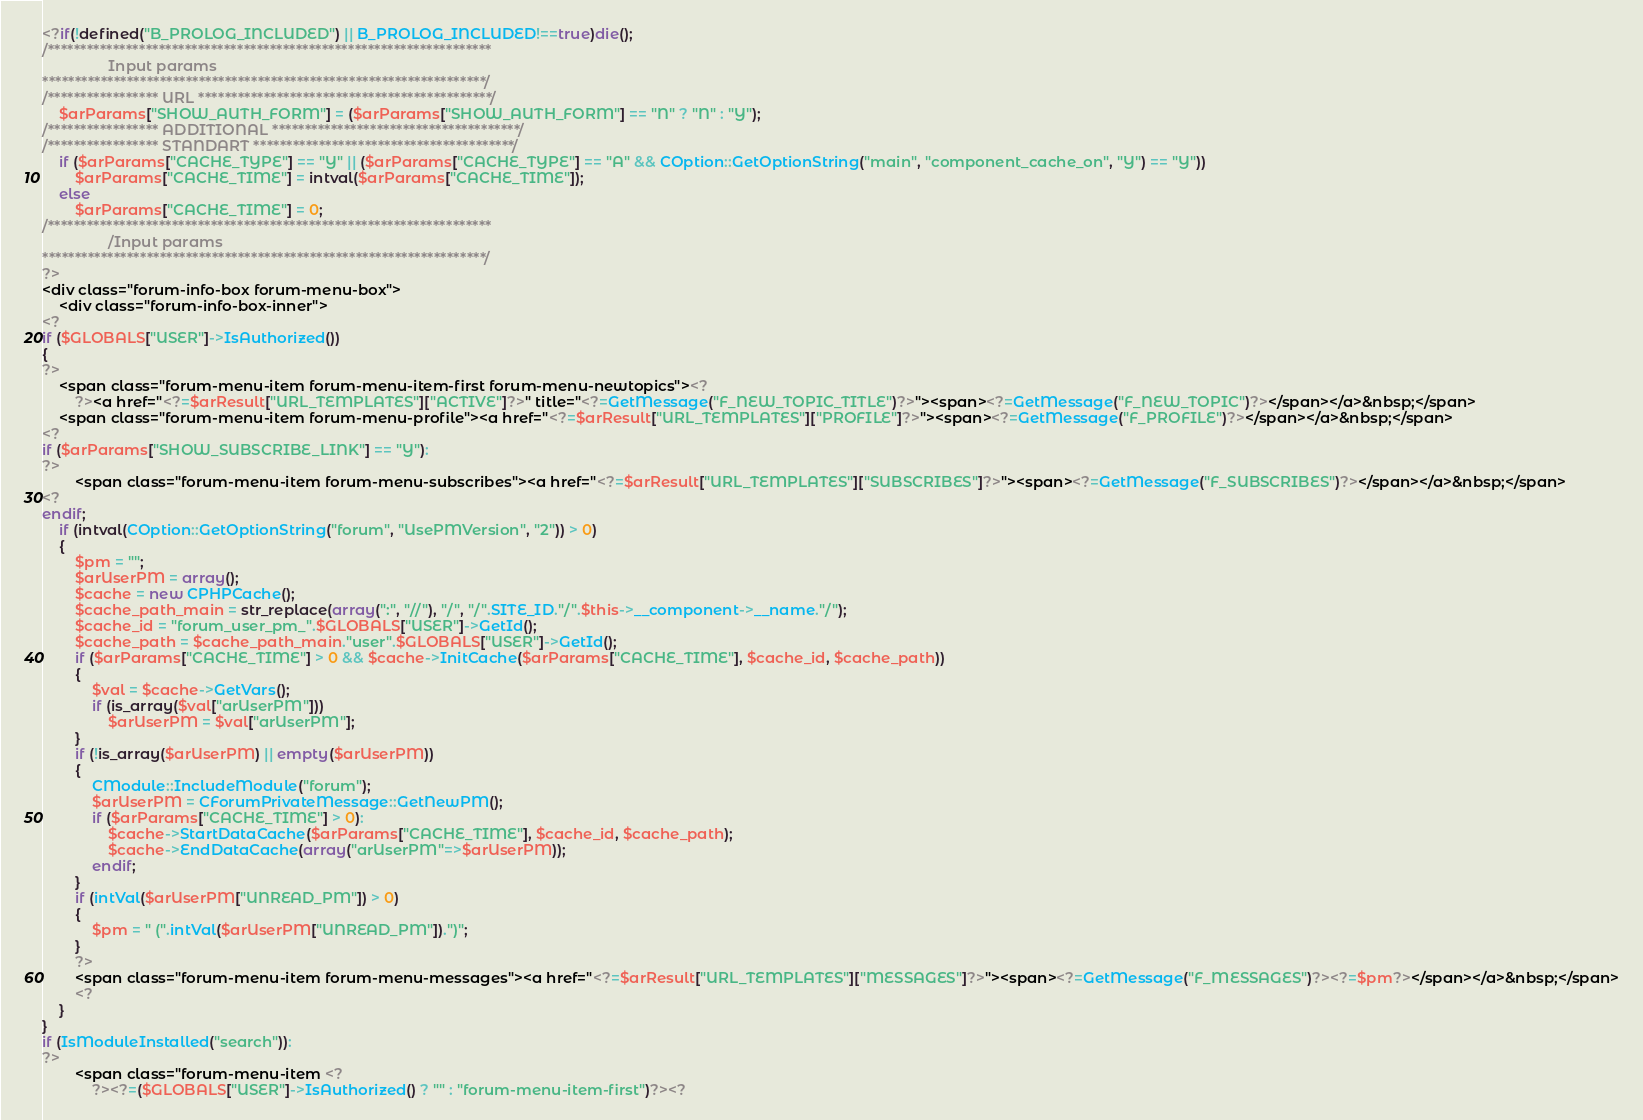Convert code to text. <code><loc_0><loc_0><loc_500><loc_500><_PHP_><?if(!defined("B_PROLOG_INCLUDED") || B_PROLOG_INCLUDED!==true)die();
/********************************************************************
				Input params
********************************************************************/
/***************** URL *********************************************/
	$arParams["SHOW_AUTH_FORM"] = ($arParams["SHOW_AUTH_FORM"] == "N" ? "N" : "Y");
/***************** ADDITIONAL **************************************/
/***************** STANDART ****************************************/
	if ($arParams["CACHE_TYPE"] == "Y" || ($arParams["CACHE_TYPE"] == "A" && COption::GetOptionString("main", "component_cache_on", "Y") == "Y"))
		$arParams["CACHE_TIME"] = intval($arParams["CACHE_TIME"]);
	else
		$arParams["CACHE_TIME"] = 0;
/********************************************************************
				/Input params
********************************************************************/
?>
<div class="forum-info-box forum-menu-box">
	<div class="forum-info-box-inner">
<?
if ($GLOBALS["USER"]->IsAuthorized())
{
?>
	<span class="forum-menu-item forum-menu-item-first forum-menu-newtopics"><?
		?><a href="<?=$arResult["URL_TEMPLATES"]["ACTIVE"]?>" title="<?=GetMessage("F_NEW_TOPIC_TITLE")?>"><span><?=GetMessage("F_NEW_TOPIC")?></span></a>&nbsp;</span>
	<span class="forum-menu-item forum-menu-profile"><a href="<?=$arResult["URL_TEMPLATES"]["PROFILE"]?>"><span><?=GetMessage("F_PROFILE")?></span></a>&nbsp;</span>
<?
if ($arParams["SHOW_SUBSCRIBE_LINK"] == "Y"):
?>
		<span class="forum-menu-item forum-menu-subscribes"><a href="<?=$arResult["URL_TEMPLATES"]["SUBSCRIBES"]?>"><span><?=GetMessage("F_SUBSCRIBES")?></span></a>&nbsp;</span>
<?
endif;
	if (intval(COption::GetOptionString("forum", "UsePMVersion", "2")) > 0)
	{
		$pm = "";
		$arUserPM = array();
		$cache = new CPHPCache();
		$cache_path_main = str_replace(array(":", "//"), "/", "/".SITE_ID."/".$this->__component->__name."/");
		$cache_id = "forum_user_pm_".$GLOBALS["USER"]->GetId();
		$cache_path = $cache_path_main."user".$GLOBALS["USER"]->GetId();
		if ($arParams["CACHE_TIME"] > 0 && $cache->InitCache($arParams["CACHE_TIME"], $cache_id, $cache_path))
		{
			$val = $cache->GetVars();
			if (is_array($val["arUserPM"]))
				$arUserPM = $val["arUserPM"];
		}
		if (!is_array($arUserPM) || empty($arUserPM))
		{
			CModule::IncludeModule("forum");
			$arUserPM = CForumPrivateMessage::GetNewPM();
			if ($arParams["CACHE_TIME"] > 0):
				$cache->StartDataCache($arParams["CACHE_TIME"], $cache_id, $cache_path);
				$cache->EndDataCache(array("arUserPM"=>$arUserPM));
			endif;
		}
		if (intVal($arUserPM["UNREAD_PM"]) > 0)
		{
			$pm = " (".intVal($arUserPM["UNREAD_PM"]).")";
		}
		?>
		<span class="forum-menu-item forum-menu-messages"><a href="<?=$arResult["URL_TEMPLATES"]["MESSAGES"]?>"><span><?=GetMessage("F_MESSAGES")?><?=$pm?></span></a>&nbsp;</span>
		<?
	}
}
if (IsModuleInstalled("search")):
?>
		<span class="forum-menu-item <?
			?><?=($GLOBALS["USER"]->IsAuthorized() ? "" : "forum-menu-item-first")?><?</code> 